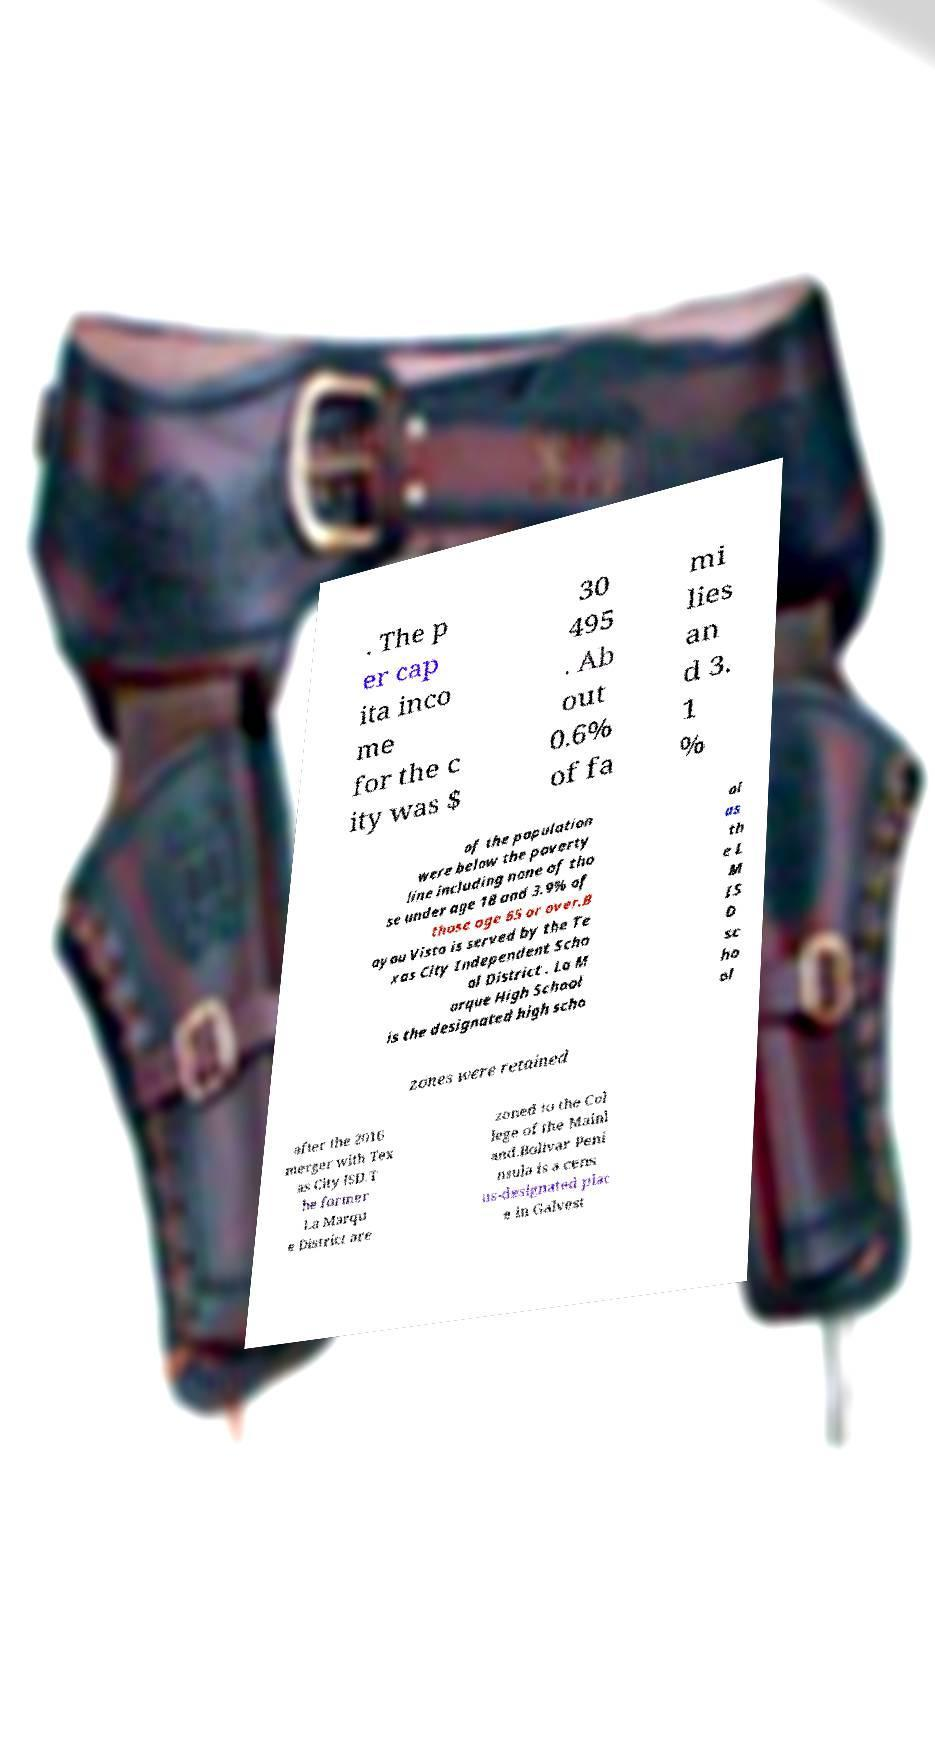Please read and relay the text visible in this image. What does it say? . The p er cap ita inco me for the c ity was $ 30 495 . Ab out 0.6% of fa mi lies an d 3. 1 % of the population were below the poverty line including none of tho se under age 18 and 3.9% of those age 65 or over.B ayou Vista is served by the Te xas City Independent Scho ol District . La M arque High School is the designated high scho ol as th e L M IS D sc ho ol zones were retained after the 2016 merger with Tex as City ISD.T he former La Marqu e District are zoned to the Col lege of the Mainl and.Bolivar Peni nsula is a cens us-designated plac e in Galvest 